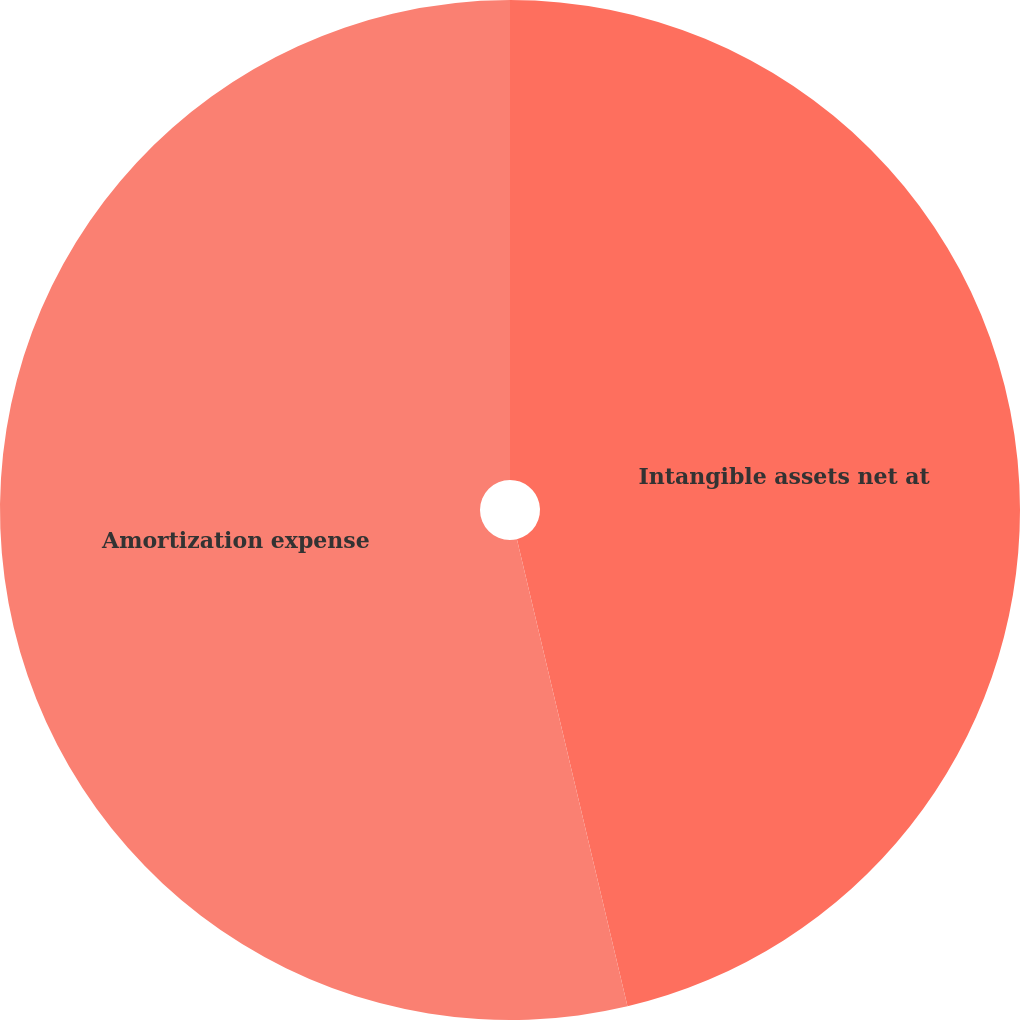<chart> <loc_0><loc_0><loc_500><loc_500><pie_chart><fcel>Intangible assets net at<fcel>Amortization expense<nl><fcel>46.3%<fcel>53.7%<nl></chart> 